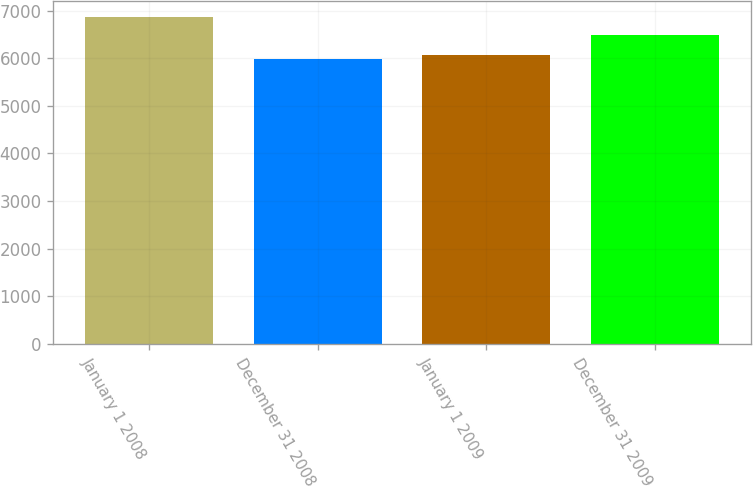Convert chart to OTSL. <chart><loc_0><loc_0><loc_500><loc_500><bar_chart><fcel>January 1 2008<fcel>December 31 2008<fcel>January 1 2009<fcel>December 31 2009<nl><fcel>6864.6<fcel>5983.4<fcel>6071.52<fcel>6484.2<nl></chart> 